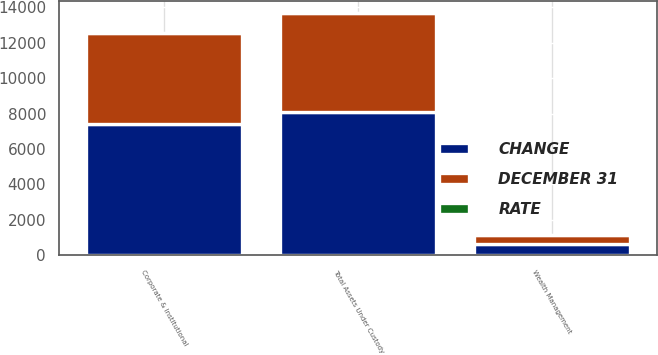Convert chart to OTSL. <chart><loc_0><loc_0><loc_500><loc_500><stacked_bar_chart><ecel><fcel>Corporate & Institutional<fcel>Wealth Management<fcel>Total Assets Under Custody<nl><fcel>CHANGE<fcel>7439.1<fcel>645.5<fcel>8084.6<nl><fcel>DECEMBER 31<fcel>5079.7<fcel>496<fcel>5575.7<nl><fcel>RATE<fcel>11<fcel>8<fcel>11<nl></chart> 